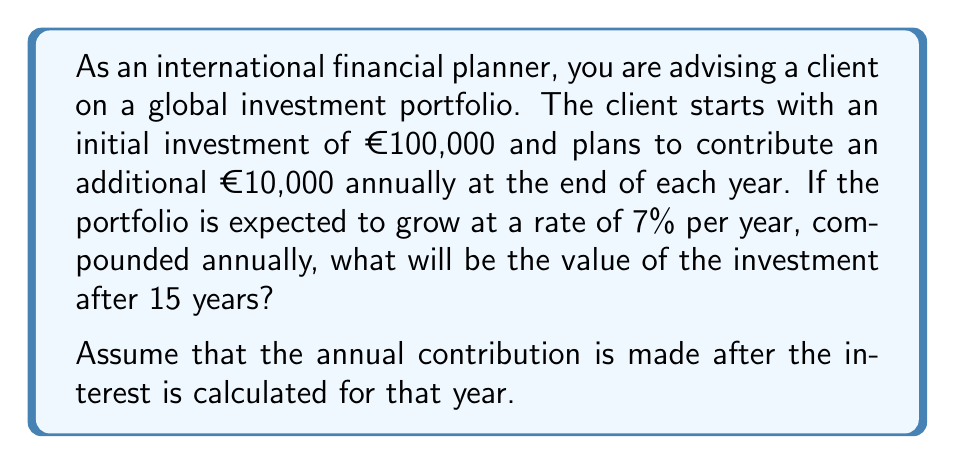Help me with this question. To solve this problem, we need to use the formula for the future value of an annuity with a growing principal. We'll break this down into two parts:

1. The growth of the initial investment
2. The growth of the annual contributions

1. For the initial investment:
   $FV_1 = P(1+r)^n$
   Where:
   $P = €100,000$ (initial principal)
   $r = 0.07$ (7% annual growth rate)
   $n = 15$ (number of years)

   $FV_1 = 100000(1+0.07)^{15} = €275,902.92$

2. For the annual contributions:
   We use the formula for future value of an annuity:
   $FV_2 = PMT \cdot \frac{(1+r)^n - 1}{r}$
   Where:
   $PMT = €10,000$ (annual contribution)
   $r = 0.07$ (7% annual growth rate)
   $n = 15$ (number of years)

   $FV_2 = 10000 \cdot \frac{(1+0.07)^{15} - 1}{0.07} = €246,726.61$

3. The total future value is the sum of these two components:
   $FV_{total} = FV_1 + FV_2$
   $FV_{total} = €275,902.92 + €246,726.61 = €522,629.53$

Therefore, after 15 years, the investment portfolio will be worth €522,629.53.
Answer: €522,629.53 